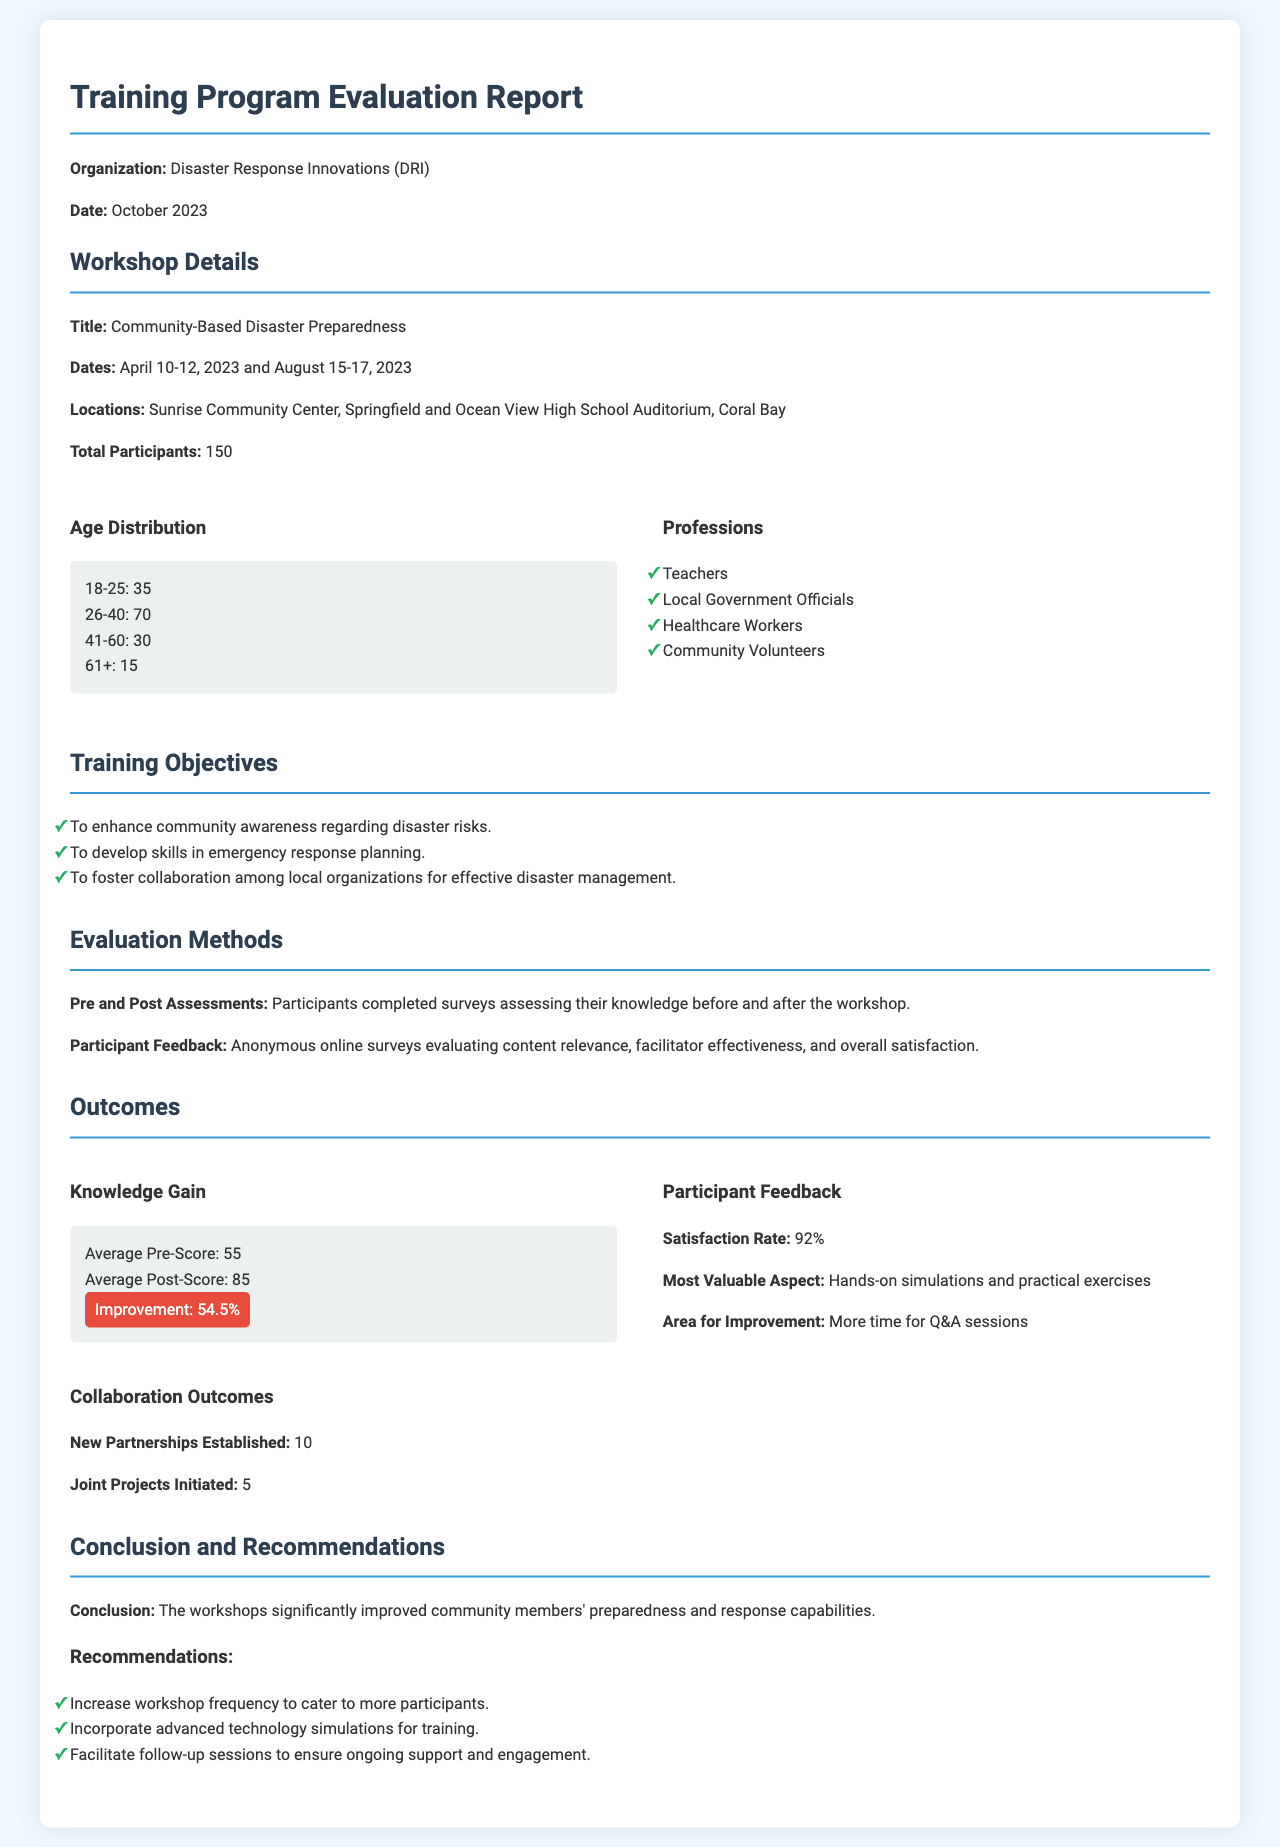what is the title of the workshop? The title of the workshop is provided in the document under the "Workshop Details" section.
Answer: Community-Based Disaster Preparedness how many participants attended the workshops in total? The total number of participants is mentioned in the "Workshop Details" section.
Answer: 150 what was the average pre-score from the assessments? The average pre-score is listed in the "Knowledge Gain" section of the "Outcomes".
Answer: 55 what percentage of participants reported satisfaction with the workshops? The satisfaction rate is noted under the "Participant Feedback" section of the "Outcomes".
Answer: 92% how many new partnerships were established as a result of the workshops? The number of new partnerships is detailed in the "Collaboration Outcomes" section.
Answer: 10 what skill was emphasized for development during the training? The training objectives specify skills to be developed which can be found in the "Training Objectives" section.
Answer: Emergency response planning what area was identified for improvement based on feedback? The area for improvement is mentioned in the "Participant Feedback" section of the "Outcomes".
Answer: More time for Q&A sessions how many joint projects were initiated following the workshops? The number of joint projects initiated is provided in the "Collaboration Outcomes" section.
Answer: 5 what is the improvement percentage in knowledge gain? The improvement percentage is highlighted in the "Knowledge Gain" section of the "Outcomes".
Answer: 54.5% 